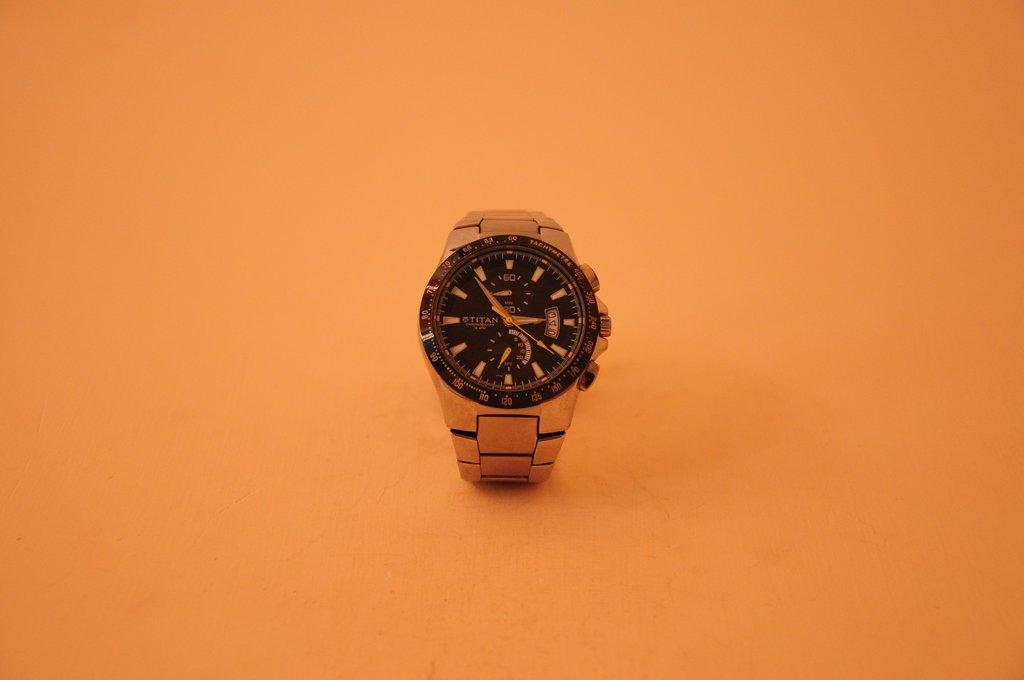Provide a one-sentence caption for the provided image. A Titan chronograph watch sits on an orange table. 